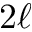<formula> <loc_0><loc_0><loc_500><loc_500>2 \ell</formula> 